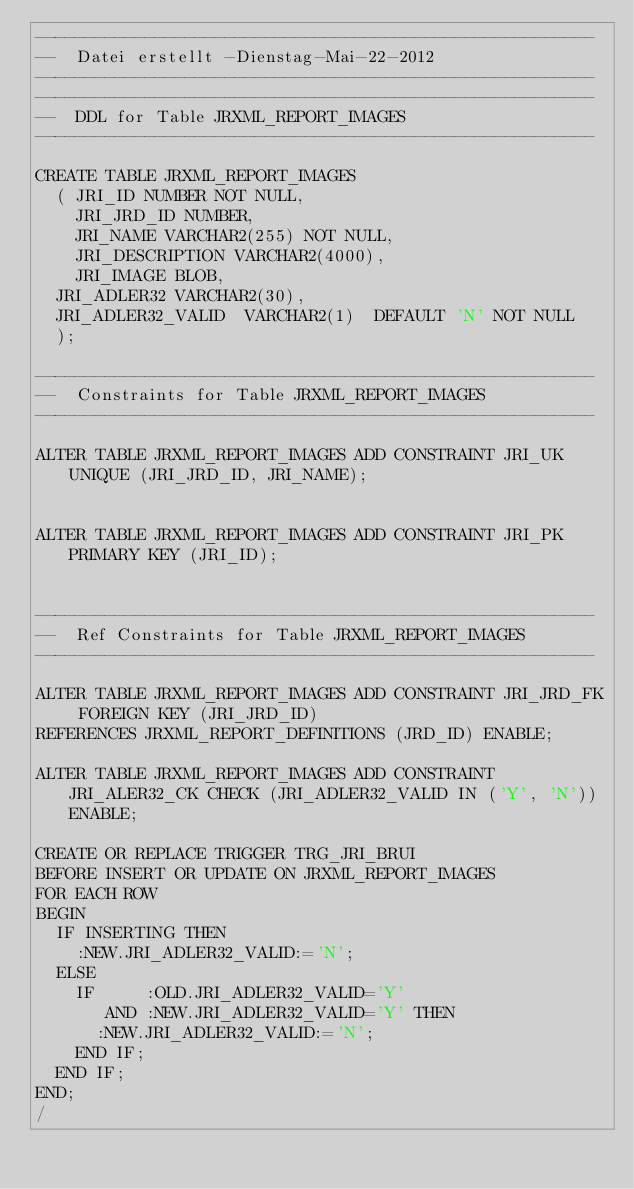<code> <loc_0><loc_0><loc_500><loc_500><_SQL_>--------------------------------------------------------
--  Datei erstellt -Dienstag-Mai-22-2012   
--------------------------------------------------------
--------------------------------------------------------
--  DDL for Table JRXML_REPORT_IMAGES
--------------------------------------------------------

CREATE TABLE JRXML_REPORT_IMAGES
  (	JRI_ID NUMBER NOT NULL, 
   	JRI_JRD_ID NUMBER, 
    JRI_NAME VARCHAR2(255) NOT NULL, 
    JRI_DESCRIPTION VARCHAR2(4000), 
   	JRI_IMAGE BLOB,
	JRI_ADLER32 VARCHAR2(30),
	JRI_ADLER32_VALID  VARCHAR2(1)  DEFAULT 'N' NOT NULL
  );

--------------------------------------------------------
--  Constraints for Table JRXML_REPORT_IMAGES
--------------------------------------------------------

ALTER TABLE JRXML_REPORT_IMAGES ADD CONSTRAINT JRI_UK UNIQUE (JRI_JRD_ID, JRI_NAME);


ALTER TABLE JRXML_REPORT_IMAGES ADD CONSTRAINT JRI_PK PRIMARY KEY (JRI_ID);


--------------------------------------------------------
--  Ref Constraints for Table JRXML_REPORT_IMAGES
--------------------------------------------------------

ALTER TABLE JRXML_REPORT_IMAGES ADD CONSTRAINT JRI_JRD_FK FOREIGN KEY (JRI_JRD_ID)
REFERENCES JRXML_REPORT_DEFINITIONS (JRD_ID) ENABLE;

ALTER TABLE JRXML_REPORT_IMAGES ADD CONSTRAINT JRI_ALER32_CK CHECK (JRI_ADLER32_VALID IN ('Y', 'N')) ENABLE;

CREATE OR REPLACE TRIGGER TRG_JRI_BRUI 
BEFORE INSERT OR UPDATE ON JRXML_REPORT_IMAGES 
FOR EACH ROW 
BEGIN
  IF INSERTING THEN 
    :NEW.JRI_ADLER32_VALID:='N';
  ELSE
    IF     :OLD.JRI_ADLER32_VALID='Y'
       AND :NEW.JRI_ADLER32_VALID='Y' THEN
      :NEW.JRI_ADLER32_VALID:='N';
    END IF;
  END IF;
END;
/</code> 